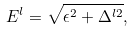Convert formula to latex. <formula><loc_0><loc_0><loc_500><loc_500>E ^ { l } = \sqrt { \epsilon ^ { 2 } + \Delta ^ { l 2 } } ,</formula> 